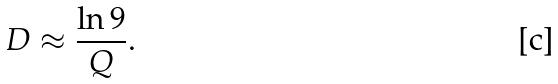Convert formula to latex. <formula><loc_0><loc_0><loc_500><loc_500>D \approx \frac { \ln 9 } { Q } .</formula> 